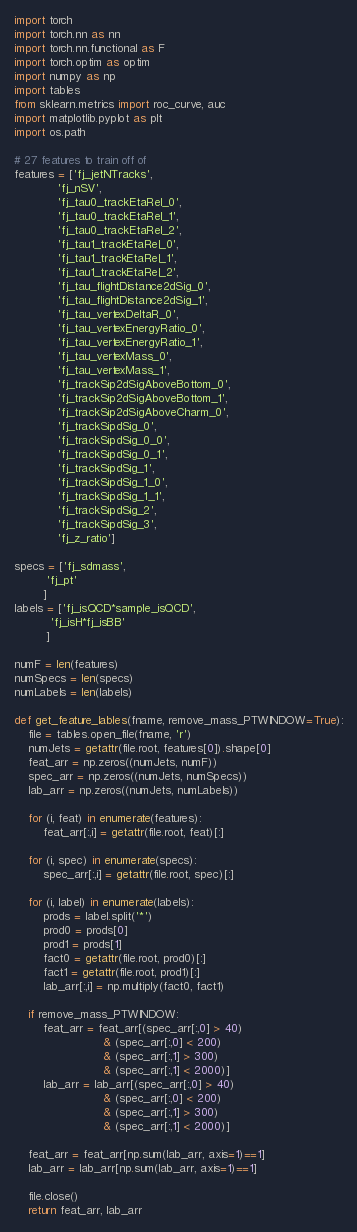<code> <loc_0><loc_0><loc_500><loc_500><_Python_>import torch
import torch.nn as nn
import torch.nn.functional as F
import torch.optim as optim
import numpy as np
import tables
from sklearn.metrics import roc_curve, auc
import matplotlib.pyplot as plt
import os.path

# 27 features to train off of
features = ['fj_jetNTracks',
            'fj_nSV',
            'fj_tau0_trackEtaRel_0',
            'fj_tau0_trackEtaRel_1',
            'fj_tau0_trackEtaRel_2',
            'fj_tau1_trackEtaRel_0',
            'fj_tau1_trackEtaRel_1',
            'fj_tau1_trackEtaRel_2',
            'fj_tau_flightDistance2dSig_0',
            'fj_tau_flightDistance2dSig_1',
            'fj_tau_vertexDeltaR_0',
            'fj_tau_vertexEnergyRatio_0',
            'fj_tau_vertexEnergyRatio_1',
            'fj_tau_vertexMass_0',
            'fj_tau_vertexMass_1',
            'fj_trackSip2dSigAboveBottom_0',
            'fj_trackSip2dSigAboveBottom_1',
            'fj_trackSip2dSigAboveCharm_0',
            'fj_trackSipdSig_0',
            'fj_trackSipdSig_0_0',
            'fj_trackSipdSig_0_1',
            'fj_trackSipdSig_1',
            'fj_trackSipdSig_1_0',
            'fj_trackSipdSig_1_1',
            'fj_trackSipdSig_2',
            'fj_trackSipdSig_3',
            'fj_z_ratio']

specs = ['fj_sdmass',
         'fj_pt'
        ]
labels = ['fj_isQCD*sample_isQCD',
          'fj_isH*fj_isBB'
         ]

numF = len(features)
numSpecs = len(specs)
numLabels = len(labels)

def get_feature_lables(fname, remove_mass_PTWINDOW=True):
    file = tables.open_file(fname, 'r')
    numJets = getattr(file.root, features[0]).shape[0]
    feat_arr = np.zeros((numJets, numF))
    spec_arr = np.zeros((numJets, numSpecs))
    lab_arr = np.zeros((numJets, numLabels))

    for (i, feat) in enumerate(features):
        feat_arr[:,i] = getattr(file.root, feat)[:]

    for (i, spec) in enumerate(specs):
        spec_arr[:,i] = getattr(file.root, spec)[:]

    for (i, label) in enumerate(labels):
        prods = label.split('*')
        prod0 = prods[0]
        prod1 = prods[1]
        fact0 = getattr(file.root, prod0)[:]
        fact1 = getattr(file.root, prod1)[:]
        lab_arr[:,i] = np.multiply(fact0, fact1)
    
    if remove_mass_PTWINDOW:
        feat_arr = feat_arr[(spec_arr[:,0] > 40)
                         & (spec_arr[:,0] < 200) 
                         & (spec_arr[:,1] > 300) 
                         & (spec_arr[:,1] < 2000)]
        lab_arr = lab_arr[(spec_arr[:,0] > 40)
                         & (spec_arr[:,0] < 200)
                         & (spec_arr[:,1] > 300)
                         & (spec_arr[:,1] < 2000)]
    
    feat_arr = feat_arr[np.sum(lab_arr, axis=1)==1]
    lab_arr = lab_arr[np.sum(lab_arr, axis=1)==1]

    file.close()
    return feat_arr, lab_arr
</code> 